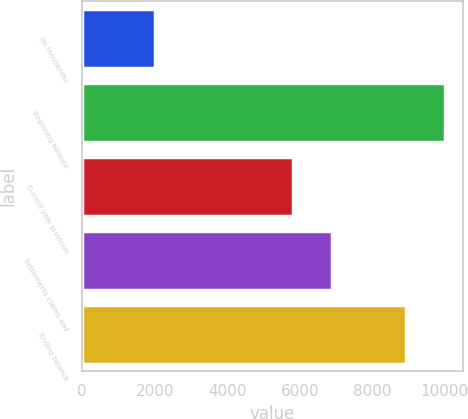<chart> <loc_0><loc_0><loc_500><loc_500><bar_chart><fcel>(in thousands)<fcel>Beginning balance<fcel>Current year provision<fcel>Settlements claims and<fcel>Ending balance<nl><fcel>2010<fcel>10000<fcel>5816<fcel>6891<fcel>8925<nl></chart> 